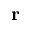Convert formula to latex. <formula><loc_0><loc_0><loc_500><loc_500>r</formula> 